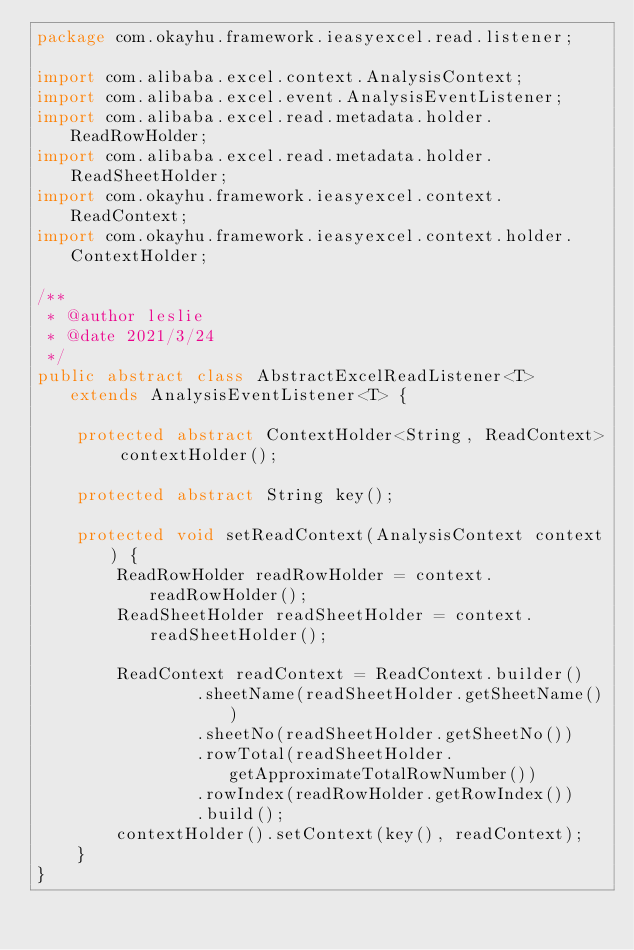<code> <loc_0><loc_0><loc_500><loc_500><_Java_>package com.okayhu.framework.ieasyexcel.read.listener;

import com.alibaba.excel.context.AnalysisContext;
import com.alibaba.excel.event.AnalysisEventListener;
import com.alibaba.excel.read.metadata.holder.ReadRowHolder;
import com.alibaba.excel.read.metadata.holder.ReadSheetHolder;
import com.okayhu.framework.ieasyexcel.context.ReadContext;
import com.okayhu.framework.ieasyexcel.context.holder.ContextHolder;

/**
 * @author leslie
 * @date 2021/3/24
 */
public abstract class AbstractExcelReadListener<T> extends AnalysisEventListener<T> {

    protected abstract ContextHolder<String, ReadContext> contextHolder();

    protected abstract String key();

    protected void setReadContext(AnalysisContext context) {
        ReadRowHolder readRowHolder = context.readRowHolder();
        ReadSheetHolder readSheetHolder = context.readSheetHolder();

        ReadContext readContext = ReadContext.builder()
                .sheetName(readSheetHolder.getSheetName())
                .sheetNo(readSheetHolder.getSheetNo())
                .rowTotal(readSheetHolder.getApproximateTotalRowNumber())
                .rowIndex(readRowHolder.getRowIndex())
                .build();
        contextHolder().setContext(key(), readContext);
    }
}
</code> 